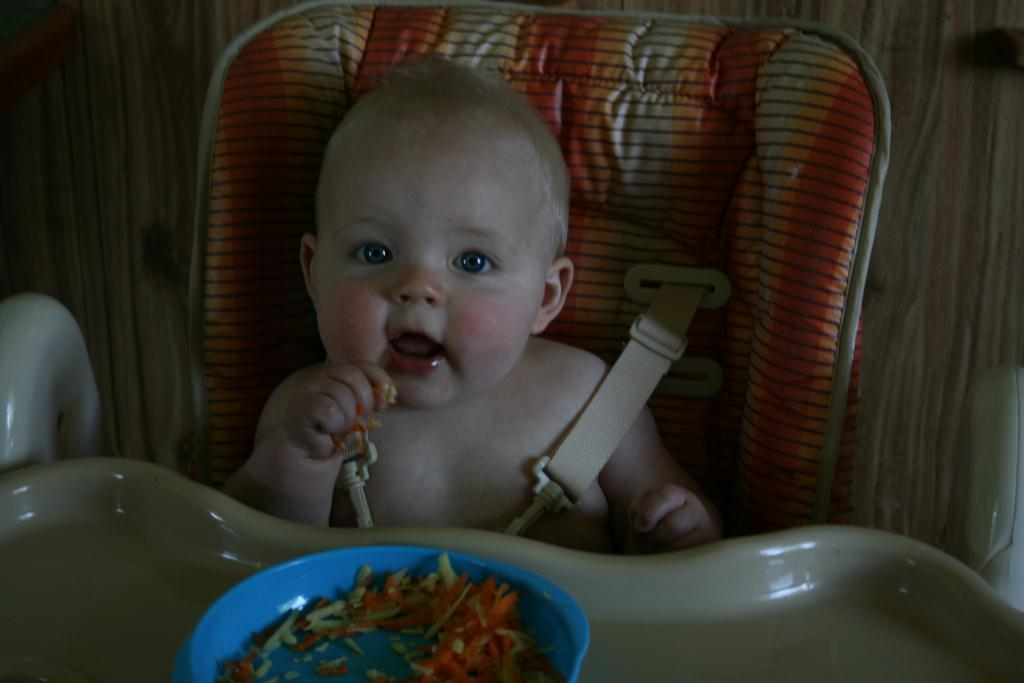What is the main subject of the image? There is a baby in the image. What is the baby doing in the image? The baby is seated on a chair. What is in front of the baby? There is a bowl of food in front of the baby. How far away is the donkey from the baby in the image? There is no donkey present in the image, so it cannot be determined how far away it might be from the baby. 